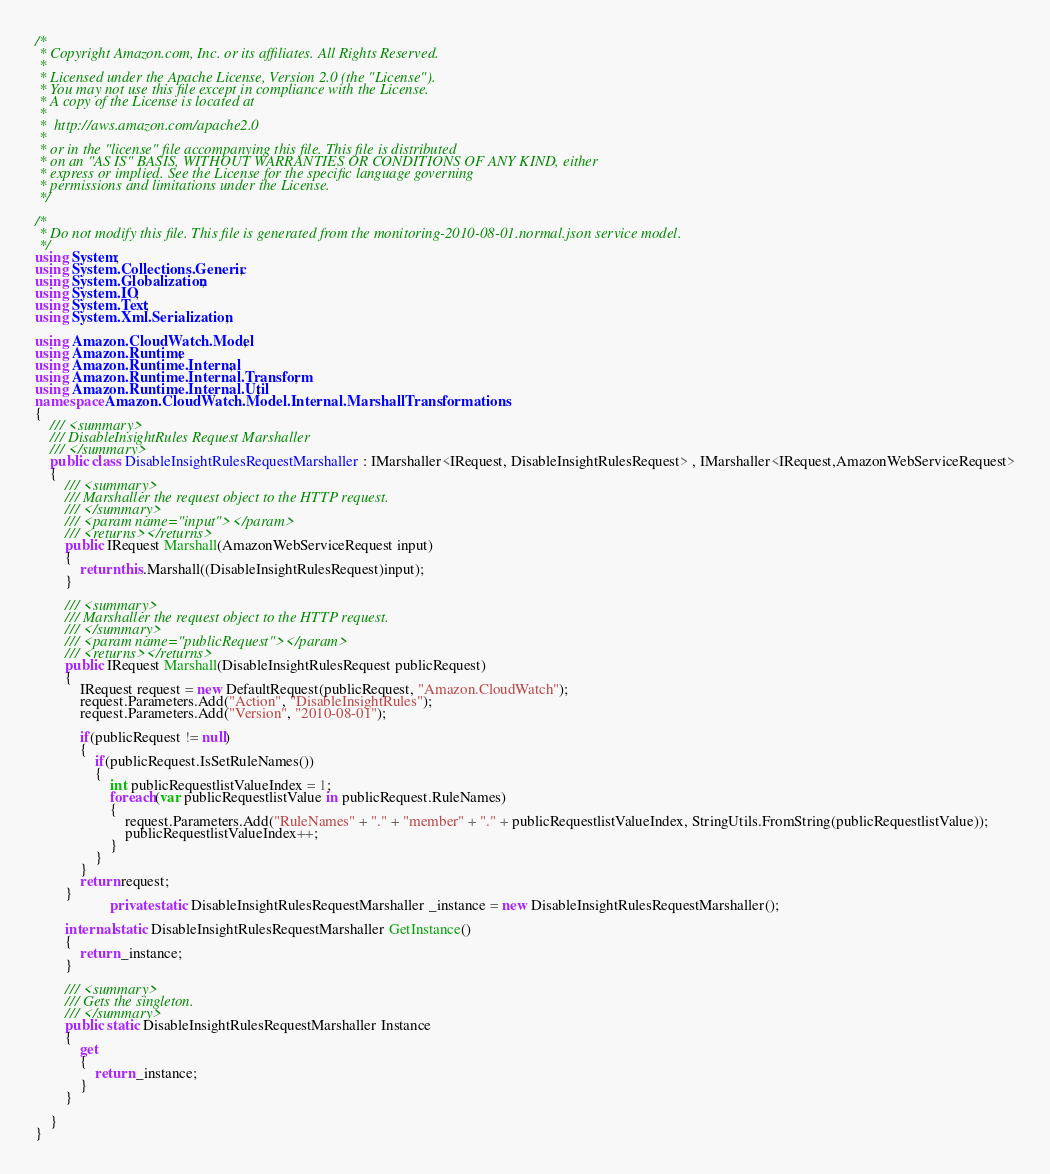Convert code to text. <code><loc_0><loc_0><loc_500><loc_500><_C#_>/*
 * Copyright Amazon.com, Inc. or its affiliates. All Rights Reserved.
 * 
 * Licensed under the Apache License, Version 2.0 (the "License").
 * You may not use this file except in compliance with the License.
 * A copy of the License is located at
 * 
 *  http://aws.amazon.com/apache2.0
 * 
 * or in the "license" file accompanying this file. This file is distributed
 * on an "AS IS" BASIS, WITHOUT WARRANTIES OR CONDITIONS OF ANY KIND, either
 * express or implied. See the License for the specific language governing
 * permissions and limitations under the License.
 */

/*
 * Do not modify this file. This file is generated from the monitoring-2010-08-01.normal.json service model.
 */
using System;
using System.Collections.Generic;
using System.Globalization;
using System.IO;
using System.Text;
using System.Xml.Serialization;

using Amazon.CloudWatch.Model;
using Amazon.Runtime;
using Amazon.Runtime.Internal;
using Amazon.Runtime.Internal.Transform;
using Amazon.Runtime.Internal.Util;
namespace Amazon.CloudWatch.Model.Internal.MarshallTransformations
{
    /// <summary>
    /// DisableInsightRules Request Marshaller
    /// </summary>       
    public class DisableInsightRulesRequestMarshaller : IMarshaller<IRequest, DisableInsightRulesRequest> , IMarshaller<IRequest,AmazonWebServiceRequest>
    {
        /// <summary>
        /// Marshaller the request object to the HTTP request.
        /// </summary>  
        /// <param name="input"></param>
        /// <returns></returns>
        public IRequest Marshall(AmazonWebServiceRequest input)
        {
            return this.Marshall((DisableInsightRulesRequest)input);
        }
    
        /// <summary>
        /// Marshaller the request object to the HTTP request.
        /// </summary>  
        /// <param name="publicRequest"></param>
        /// <returns></returns>
        public IRequest Marshall(DisableInsightRulesRequest publicRequest)
        {
            IRequest request = new DefaultRequest(publicRequest, "Amazon.CloudWatch");
            request.Parameters.Add("Action", "DisableInsightRules");
            request.Parameters.Add("Version", "2010-08-01");

            if(publicRequest != null)
            {
                if(publicRequest.IsSetRuleNames())
                {
                    int publicRequestlistValueIndex = 1;
                    foreach(var publicRequestlistValue in publicRequest.RuleNames)
                    {
                        request.Parameters.Add("RuleNames" + "." + "member" + "." + publicRequestlistValueIndex, StringUtils.FromString(publicRequestlistValue));
                        publicRequestlistValueIndex++;
                    }
                }
            }
            return request;
        }
                    private static DisableInsightRulesRequestMarshaller _instance = new DisableInsightRulesRequestMarshaller();        

        internal static DisableInsightRulesRequestMarshaller GetInstance()
        {
            return _instance;
        }

        /// <summary>
        /// Gets the singleton.
        /// </summary>  
        public static DisableInsightRulesRequestMarshaller Instance
        {
            get
            {
                return _instance;
            }
        }

    }
}</code> 